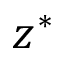Convert formula to latex. <formula><loc_0><loc_0><loc_500><loc_500>z ^ { * }</formula> 